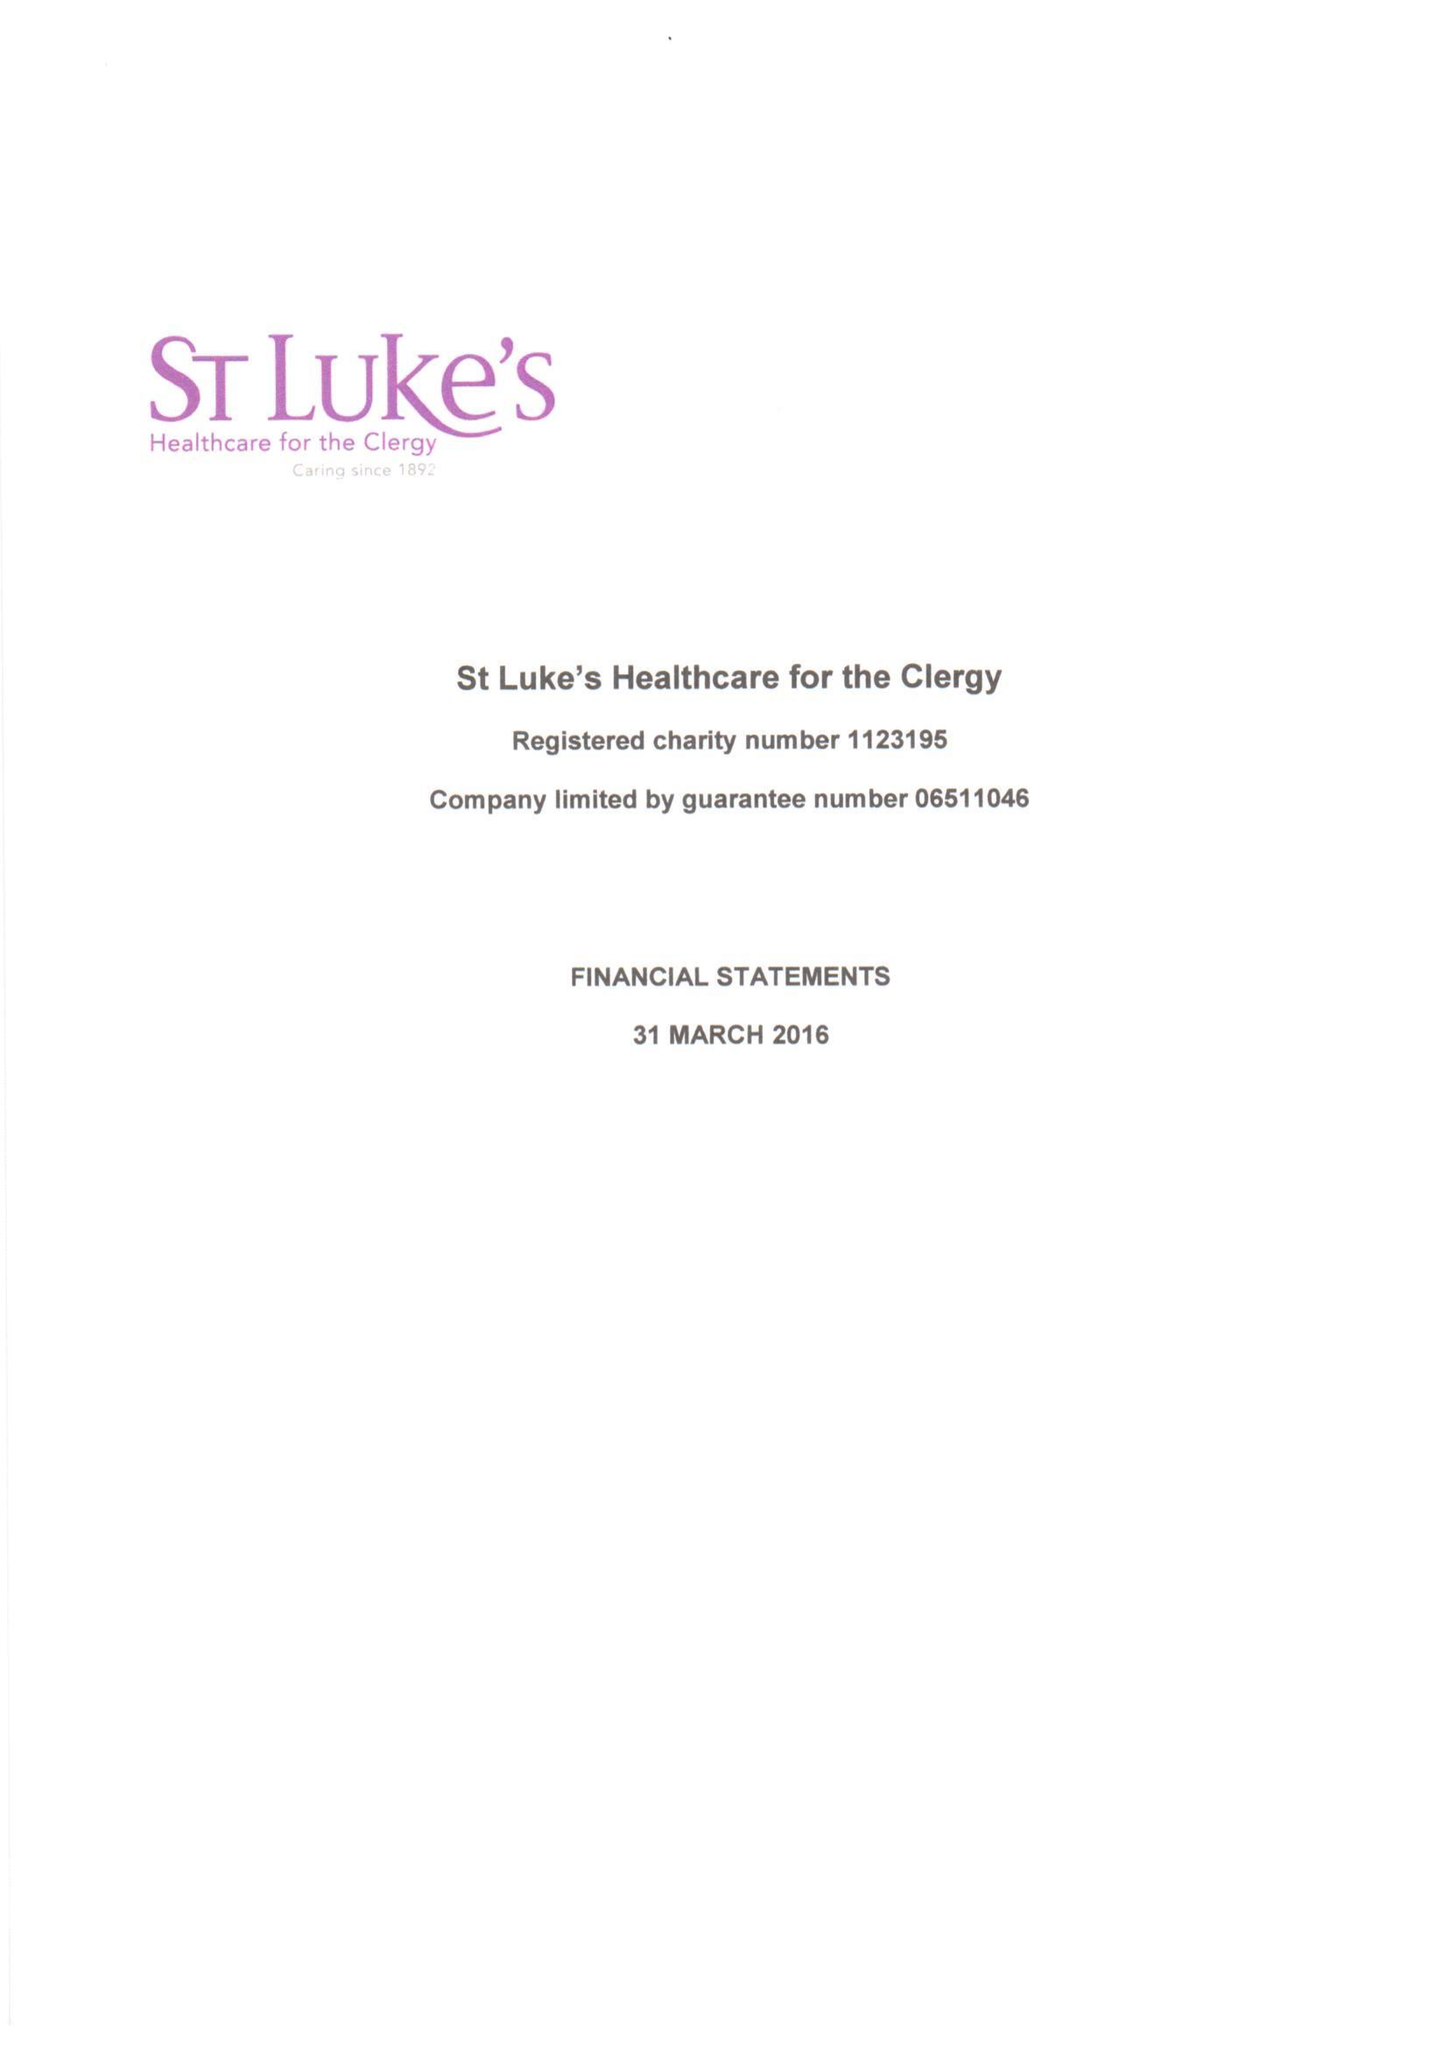What is the value for the spending_annually_in_british_pounds?
Answer the question using a single word or phrase. 447359.00 